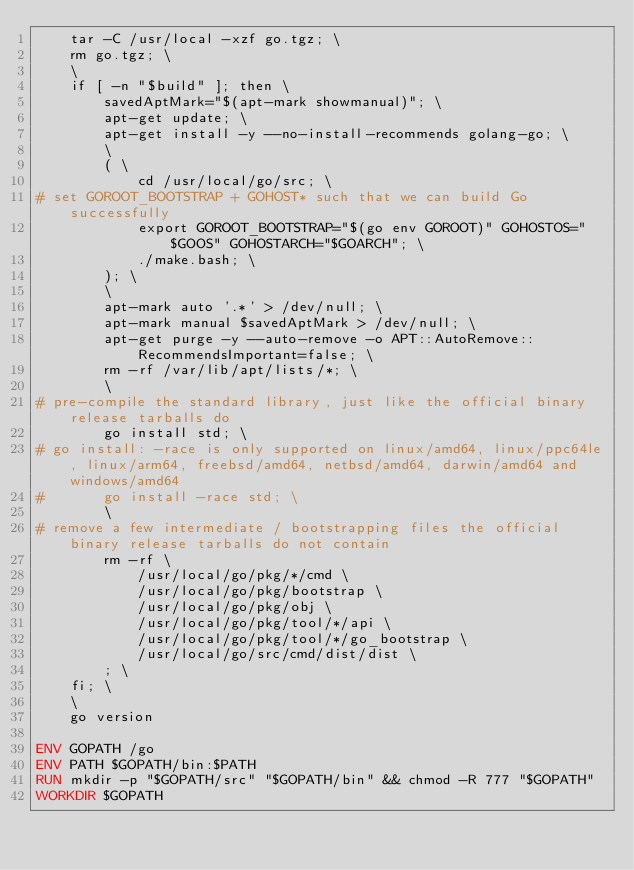<code> <loc_0><loc_0><loc_500><loc_500><_Dockerfile_>	tar -C /usr/local -xzf go.tgz; \
	rm go.tgz; \
	\
	if [ -n "$build" ]; then \
		savedAptMark="$(apt-mark showmanual)"; \
		apt-get update; \
		apt-get install -y --no-install-recommends golang-go; \
		\
		( \
			cd /usr/local/go/src; \
# set GOROOT_BOOTSTRAP + GOHOST* such that we can build Go successfully
			export GOROOT_BOOTSTRAP="$(go env GOROOT)" GOHOSTOS="$GOOS" GOHOSTARCH="$GOARCH"; \
			./make.bash; \
		); \
		\
		apt-mark auto '.*' > /dev/null; \
		apt-mark manual $savedAptMark > /dev/null; \
		apt-get purge -y --auto-remove -o APT::AutoRemove::RecommendsImportant=false; \
		rm -rf /var/lib/apt/lists/*; \
		\
# pre-compile the standard library, just like the official binary release tarballs do
		go install std; \
# go install: -race is only supported on linux/amd64, linux/ppc64le, linux/arm64, freebsd/amd64, netbsd/amd64, darwin/amd64 and windows/amd64
#		go install -race std; \
		\
# remove a few intermediate / bootstrapping files the official binary release tarballs do not contain
		rm -rf \
			/usr/local/go/pkg/*/cmd \
			/usr/local/go/pkg/bootstrap \
			/usr/local/go/pkg/obj \
			/usr/local/go/pkg/tool/*/api \
			/usr/local/go/pkg/tool/*/go_bootstrap \
			/usr/local/go/src/cmd/dist/dist \
		; \
	fi; \
	\
	go version

ENV GOPATH /go
ENV PATH $GOPATH/bin:$PATH
RUN mkdir -p "$GOPATH/src" "$GOPATH/bin" && chmod -R 777 "$GOPATH"
WORKDIR $GOPATH
</code> 